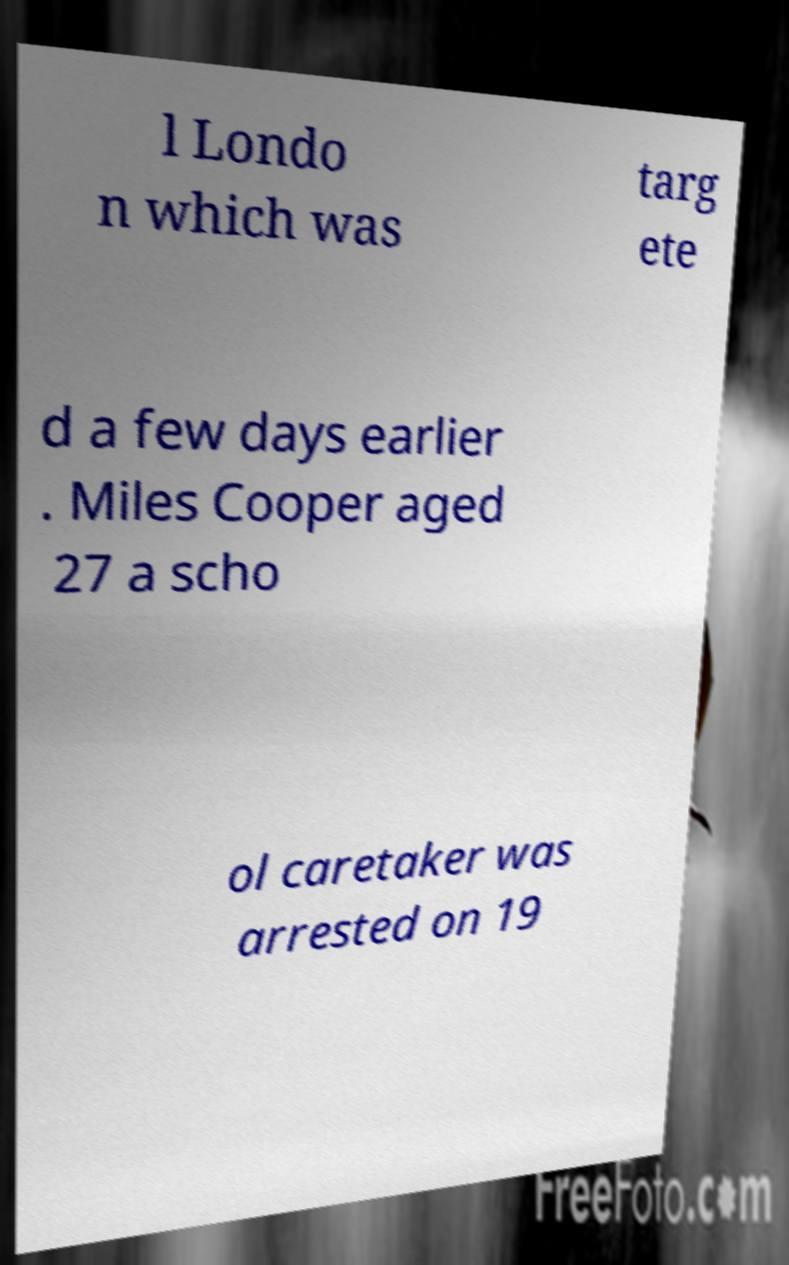I need the written content from this picture converted into text. Can you do that? l Londo n which was targ ete d a few days earlier . Miles Cooper aged 27 a scho ol caretaker was arrested on 19 